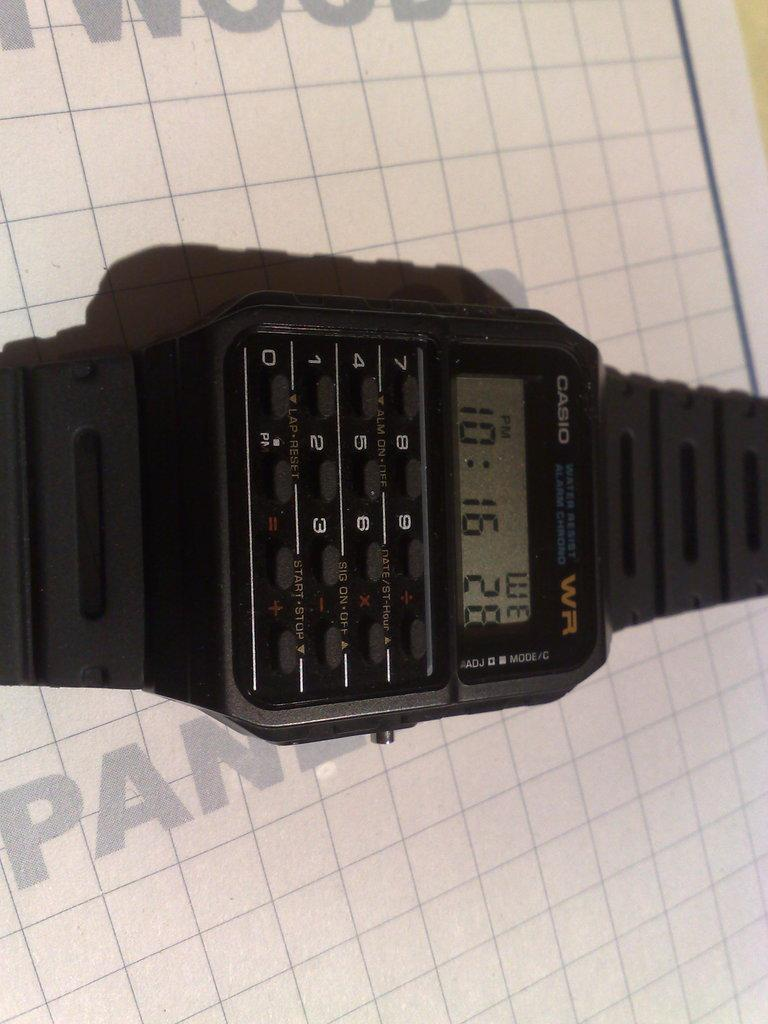<image>
Write a terse but informative summary of the picture. The Casio watch on display has the time at 10:16 PM. 